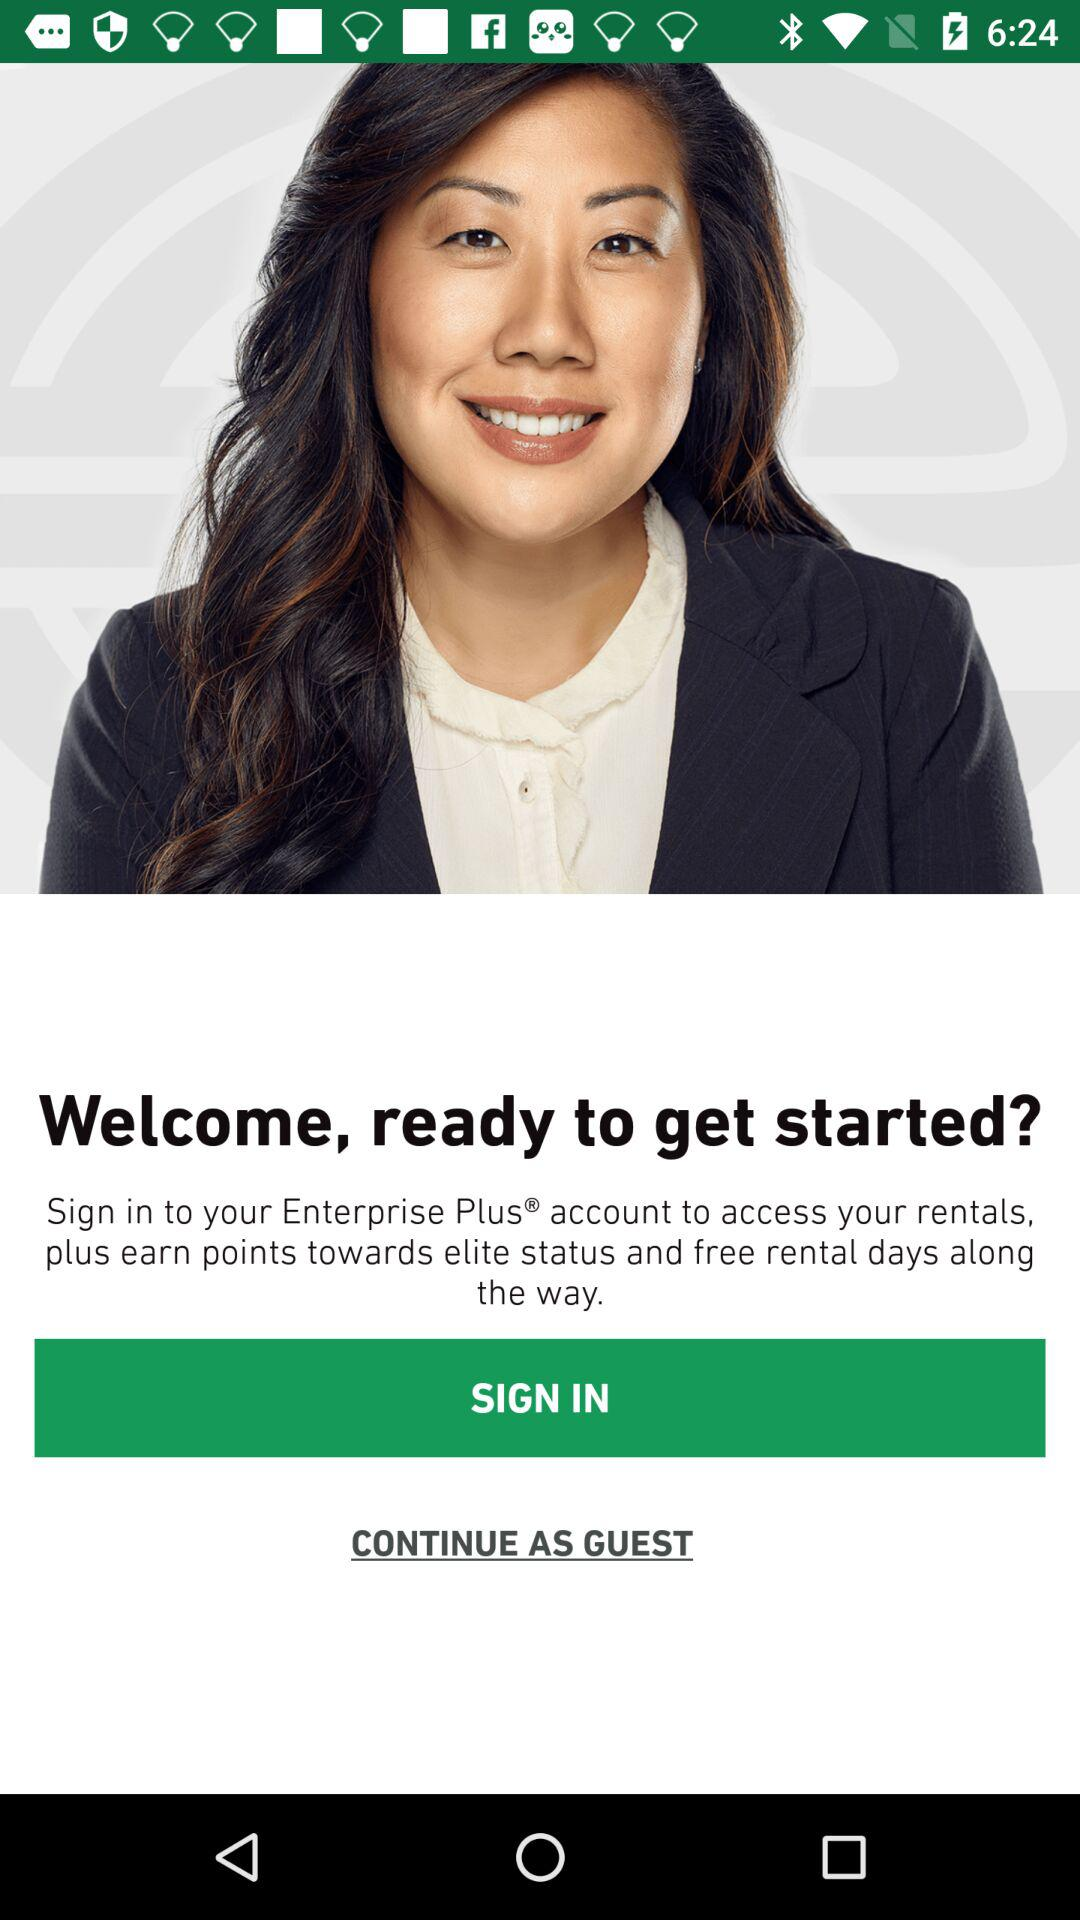What account do I need to sign in to access rentals? You need to sign in to your Enterprise Plus account to access rentals. 